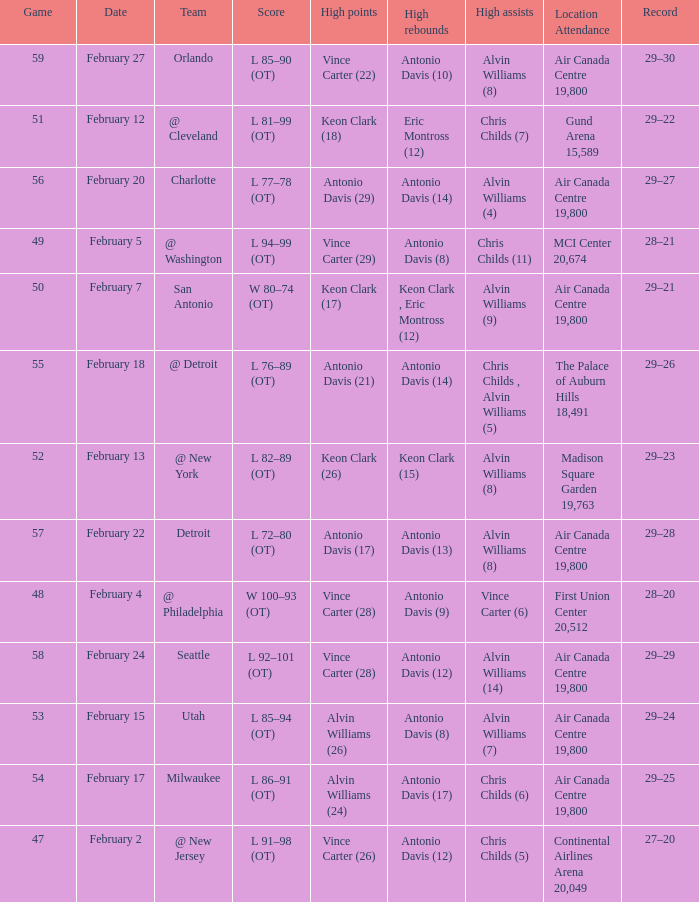What is the Team with a game of more than 56, and the score is l 85–90 (ot)? Orlando. 